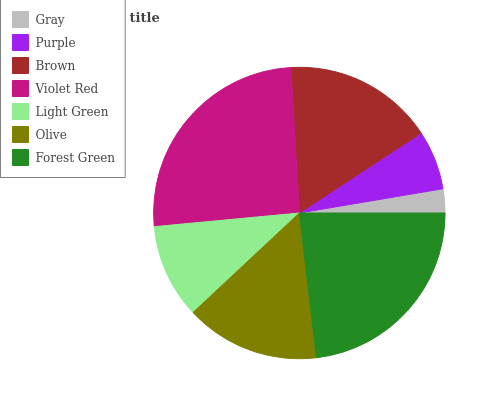Is Gray the minimum?
Answer yes or no. Yes. Is Violet Red the maximum?
Answer yes or no. Yes. Is Purple the minimum?
Answer yes or no. No. Is Purple the maximum?
Answer yes or no. No. Is Purple greater than Gray?
Answer yes or no. Yes. Is Gray less than Purple?
Answer yes or no. Yes. Is Gray greater than Purple?
Answer yes or no. No. Is Purple less than Gray?
Answer yes or no. No. Is Olive the high median?
Answer yes or no. Yes. Is Olive the low median?
Answer yes or no. Yes. Is Gray the high median?
Answer yes or no. No. Is Gray the low median?
Answer yes or no. No. 